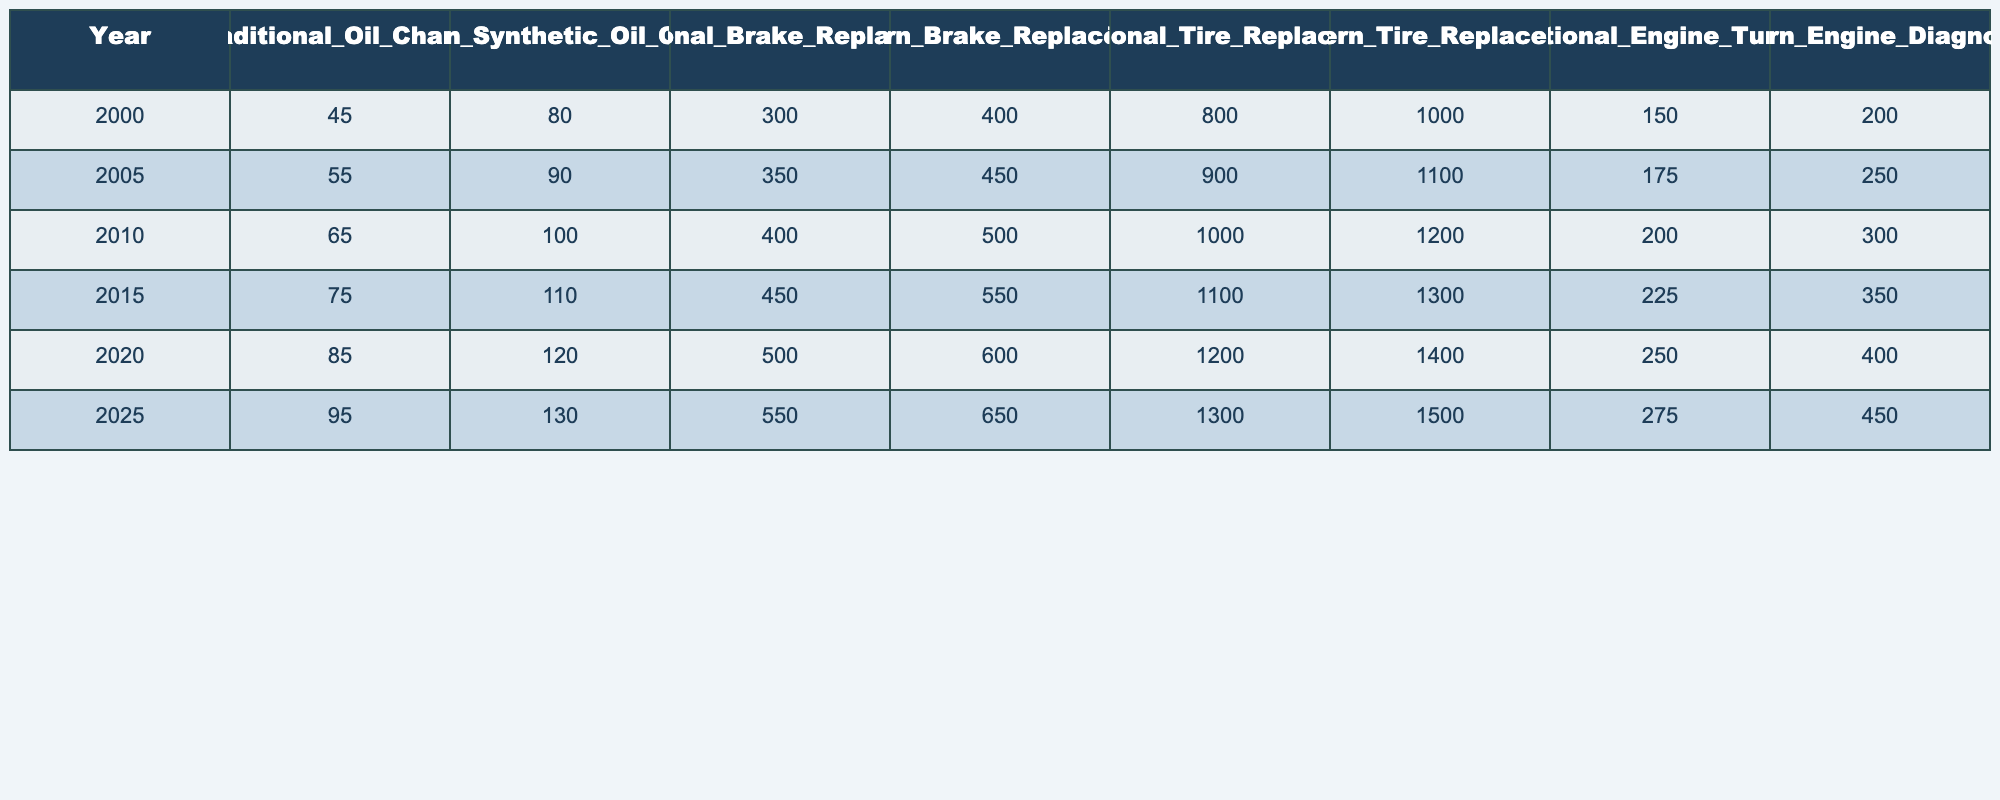What was the cost of a traditional oil change in 2010? Looking at the table, in the year 2010, the cost of a traditional oil change is listed as 65.
Answer: 65 What is the difference in cost for brake replacement between traditional and modern methods in 2020? For traditional brake replacement in 2020, the cost is 500, and for modern, it is 600. The difference is 600 - 500 = 100.
Answer: 100 Is the cost of modern tire replacement always higher than traditional tire replacement? By comparing the values in the table for each year, modern tire replacement is consistently higher than traditional tire replacement in all years listed.
Answer: Yes What was the total cost of traditional maintenance (oil change, brake replacement, tire replacement) in 2015? The costs in 2015 are 75 (oil change) + 450 (brake replacement) + 1100 (tire replacement), which totals to 75 + 450 + 1100 = 1625.
Answer: 1625 In which year did the cost of modern engine diagnostics first exceed traditional engine tune-ups? In 2020, the cost for modern engine diagnostics is 400, which is higher than the traditional engine tune-up cost of 250 for the same year, making 2020 the first year this occurs.
Answer: 2020 What is the average cost of traditional oil changes over the years listed? The costs for traditional oil changes are 45, 55, 65, 75, 85, and 95. Adding these up (45 + 55 + 65 + 75 + 85 + 95 = 405) and dividing by the number of years (6) gives 405/6 = 67.5.
Answer: 67.5 In which year is the cost of modern synthetic oil change the highest? Reviewing the costs of modern synthetic oil changes across the years, the highest value is 130 in 2025.
Answer: 2025 What is the percentage increase in the cost of traditional tire replacement from 2000 to 2025? The cost in 2000 is 800, and in 2025 it is 1300. The increase is 1300 - 800 = 500. The percentage increase is (500 / 800) * 100 = 62.5%.
Answer: 62.5% Was the cost of modern engine diagnostics ever lower than traditional engine tune-ups? By analyzing the table, modern engine diagnostics has always been higher than traditional engine tune-ups for each year listed.
Answer: No What is the total cost for all modern maintenance methods combined in the year 2025? Adding the modern maintenance costs in 2025 gives 130 (oil change) + 650 (brake replacement) + 1500 (tire replacement) + 450 (engine diagnostics) = 2730.
Answer: 2730 